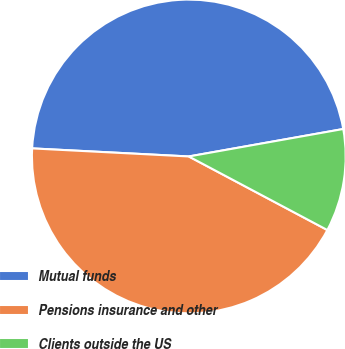Convert chart. <chart><loc_0><loc_0><loc_500><loc_500><pie_chart><fcel>Mutual funds<fcel>Pensions insurance and other<fcel>Clients outside the US<nl><fcel>46.38%<fcel>43.05%<fcel>10.57%<nl></chart> 